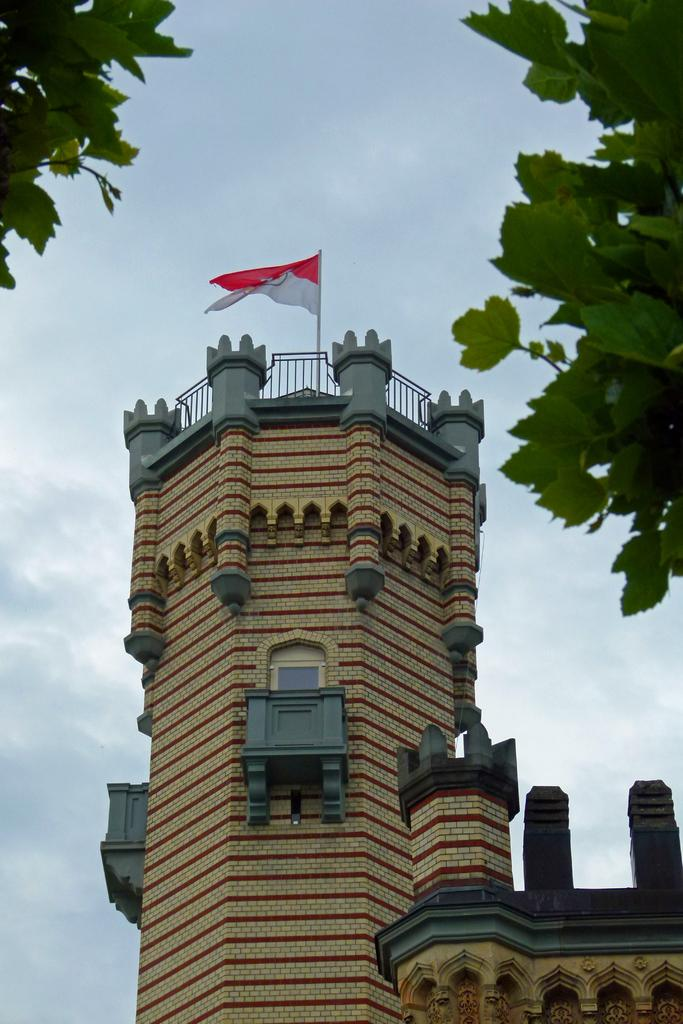What type of structure is in the image? There is a fort in the image. What is located at the top of the fort? A flag and leaves are visible at the top of the fort. What can be seen in the middle of the image? The sky is visible in the middle of the image. What type of holiday is being celebrated in the image? There is no indication of a holiday being celebrated in the image. How many twigs are present in the image? There is no mention of twigs in the image. 